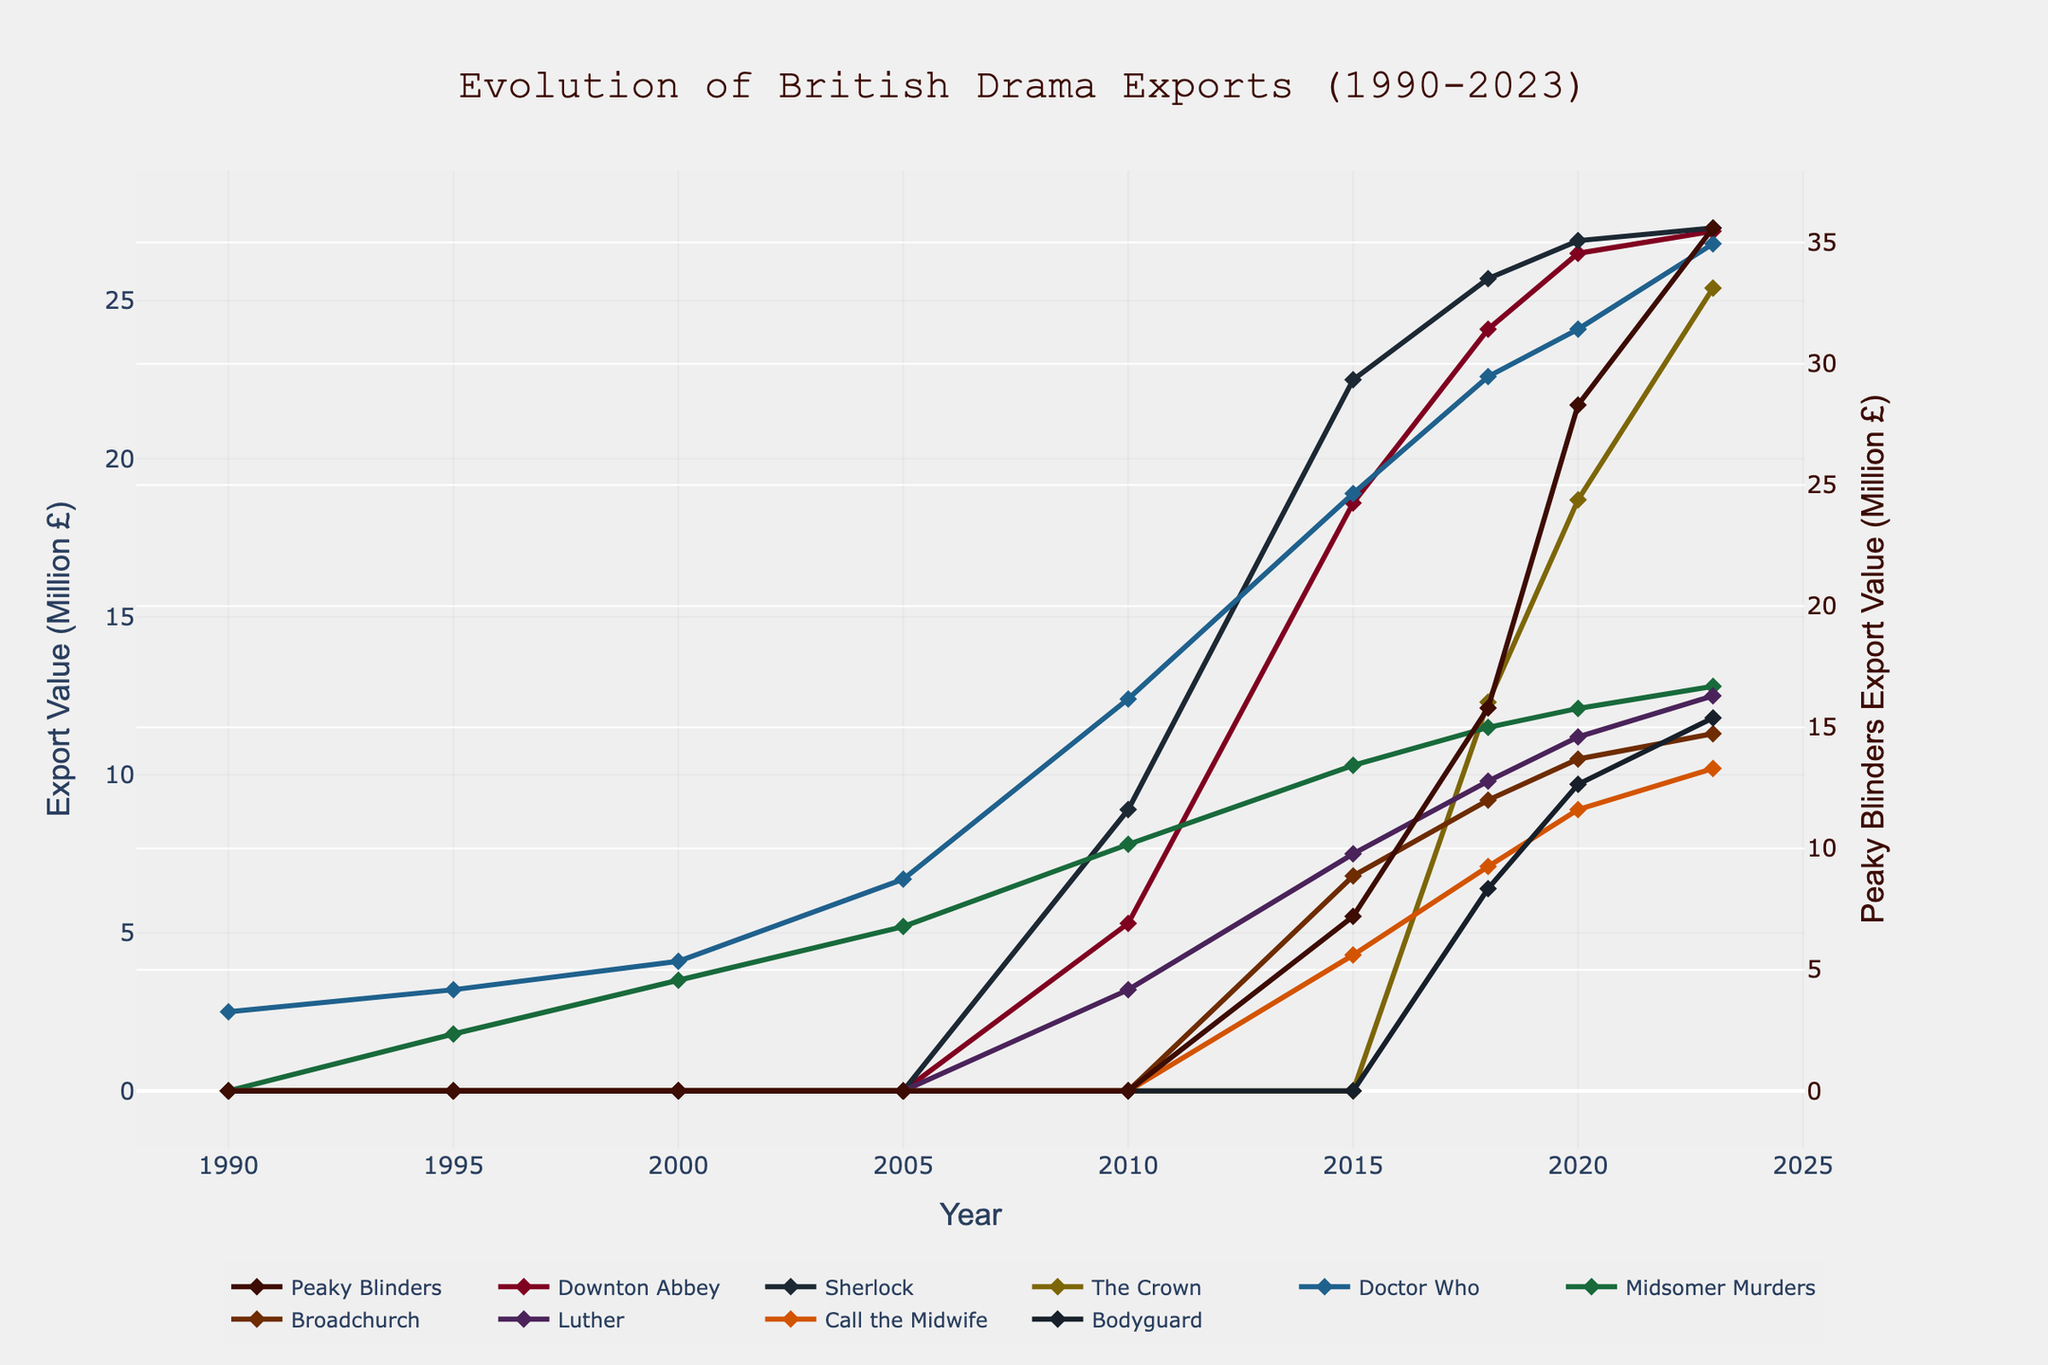What year did Peaky Blinders first appear in the export data? To find this, we examine the values for Peaky Blinders starting from the left of the graph. The first non-zero value appears in 2015.
Answer: 2015 How does the export value of Peaky Blinders in 2023 compare to Downton Abbey in the same year? Look at the values for Peaky Blinders and Downton Abbey in 2023. Peaky Blinders is at 35.6 million £, while Downton Abbey is at 27.2 million £. Thus, Peaky Blinders has a higher export value.
Answer: Peaky Blinders is higher In which year did Sherlock reach its peak export value? To find this, trace the export values for Sherlock across all years and identify the year with the highest value. Sherlock reaches its peak value in 2018 with 25.7 million £.
Answer: 2018 What is the combined export value of The Crown and Doctor Who in 2020? Identify the export values of The Crown and Doctor Who for 2020, which are 18.7 and 24.1 million £ respectively. Summing these values gives 18.7 + 24.1 = 42.8 million £.
Answer: 42.8 million £ Between 2015 and 2018, which drama saw the largest increase in export value? Calculate the increase for each drama by subtracting the 2015 value from the 2018 value. The increase for Peaky Blinders is 15.8 - 7.2 = 8.6, for Downton Abbey is 24.1 - 18.6 = 5.5, for Sherlock is 25.7 - 22.5 = 3.2, for The Crown is 12.3 - 0 = 12.3, for Doctor Who is 22.6 - 18.9 = 3.7, for Midsomer Murders is 11.5 - 10.3 = 1.2, for Broadchurch is 9.2 - 6.8 = 2.4, for Luther is 9.8 - 7.5 = 2.3, for Call the Midwife is 7.1 - 4.3 = 2.8, and for Bodyguard it is 6.4 - 0 = 6.4. The Crown saw the largest increase.
Answer: The Crown What was the export value trend for Doctor Who between 2000 and 2010? Check the export values of Doctor Who in 2000, 2005, and 2010. The values are 4.1 million £ in 2000, 6.7 million £ in 2005, and 12.4 million £ in 2010. The trend shows an increasing value.
Answer: Increasing What's the average export value of Call the Midwife from 2018 to 2023? Sum the export values of Call the Midwife from 2018 to 2023 (7.1 + 8.9 + 10.2 = 26.2) and divide by the number of years (3). The average is 26.2 / 3 ≈ 8.73 million £.
Answer: 8.73 million £ Compare the export values of Bodyguard in 2018 and 2023. How much did it increase? Check the values for Bodyguard in 2018 and 2023. They are 6.4 million £ and 11.8 million £ respectively. Subtract 6.4 from 11.8 to find the increase: 11.8 - 6.4 = 5.4 million £.
Answer: 5.4 million £ 